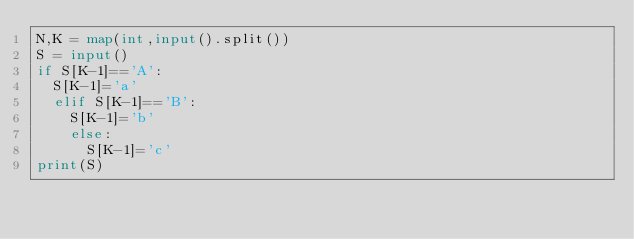Convert code to text. <code><loc_0><loc_0><loc_500><loc_500><_Python_>N,K = map(int,input().split())
S = input()
if S[K-1]=='A':
  S[K-1]='a'
  elif S[K-1]=='B':
    S[K-1]='b'
    else:
      S[K-1]='c'
print(S)</code> 